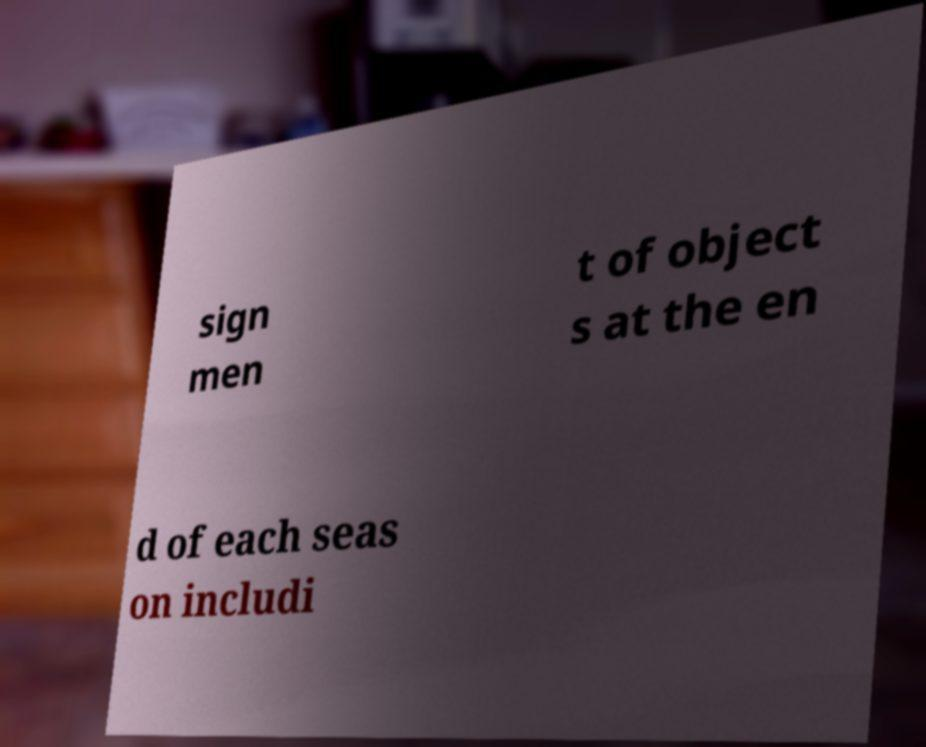For documentation purposes, I need the text within this image transcribed. Could you provide that? sign men t of object s at the en d of each seas on includi 